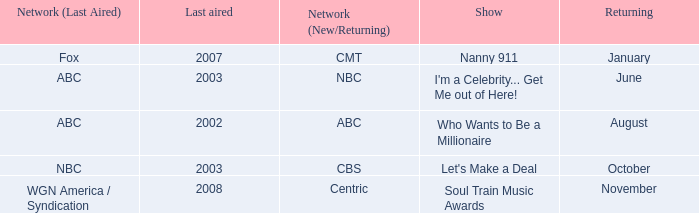When did soul train music awards return? November. 